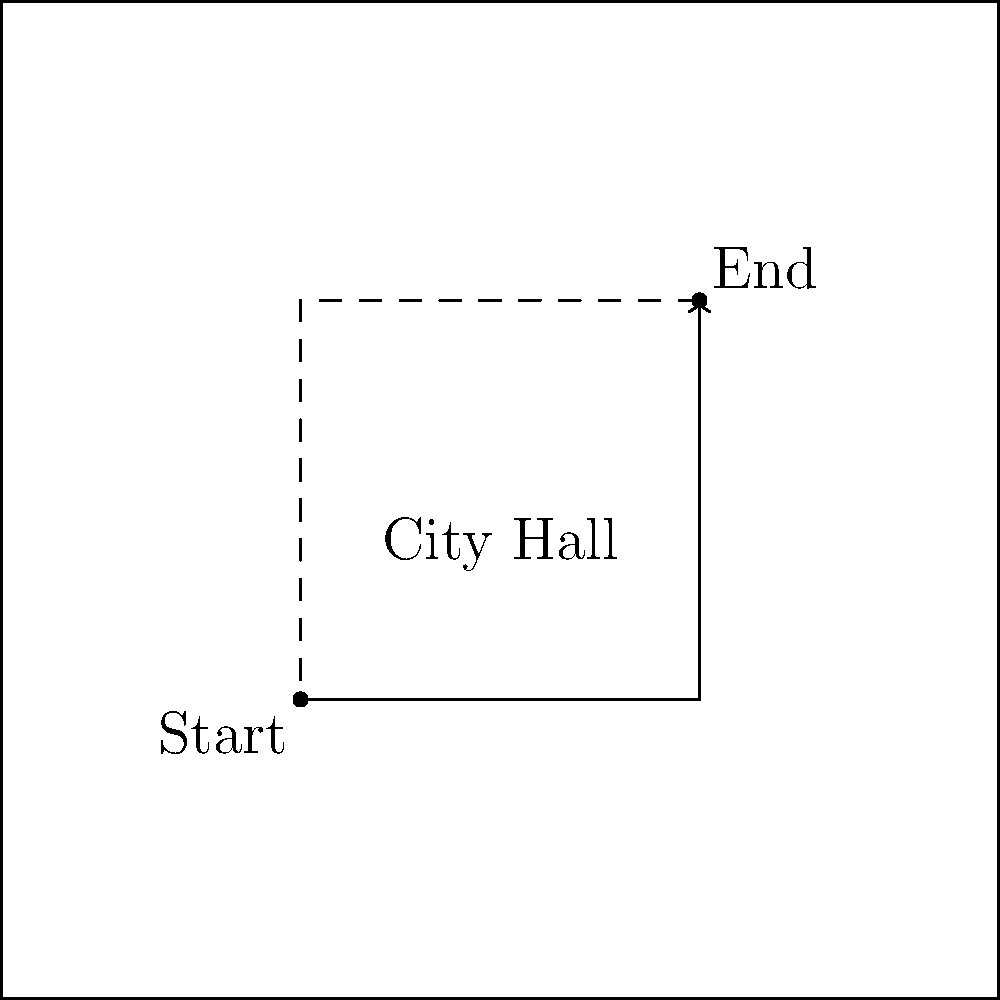As a retired police officer advising on protest organization, consider the city map above showing a proposed march route from point E to point G. The dashed line represents the boundaries of the central business district, and City Hall is located at the center. What modification to the route would you suggest to maximize visibility and minimize disruption? To answer this question, we need to consider several factors:

1. Visibility: The protest should be visible to as many people as possible to effectively convey its message.
2. Minimal disruption: As a former police officer, you understand the importance of balancing the right to protest with minimizing disruption to daily city life.
3. Symbolism: Passing by important locations like City Hall can add significance to the protest.
4. Safety: The route should allow for easy crowd management and emergency access.

Considering these factors:

1. The current route (E-F-G) passes through the business district but doesn't approach City Hall.
2. A route that circles City Hall would increase visibility and symbolic impact.
3. Using the perimeter of the business district (E-F-G-H-E) would maximize visibility while containing the protest to a defined area.

The optimal modification would be to change the route to E-F-G-H-E, circling the entire business district and City Hall. This route:

1. Maximizes visibility by covering all sides of the business district.
2. Passes close to City Hall, adding symbolic significance.
3. Creates a loop, allowing for better crowd management and easier dispersal at the end.
4. Keeps the protest contained within a defined area, minimizing disruption to the wider city.
Answer: Modify route to E-F-G-H-E, circling the business district and City Hall. 